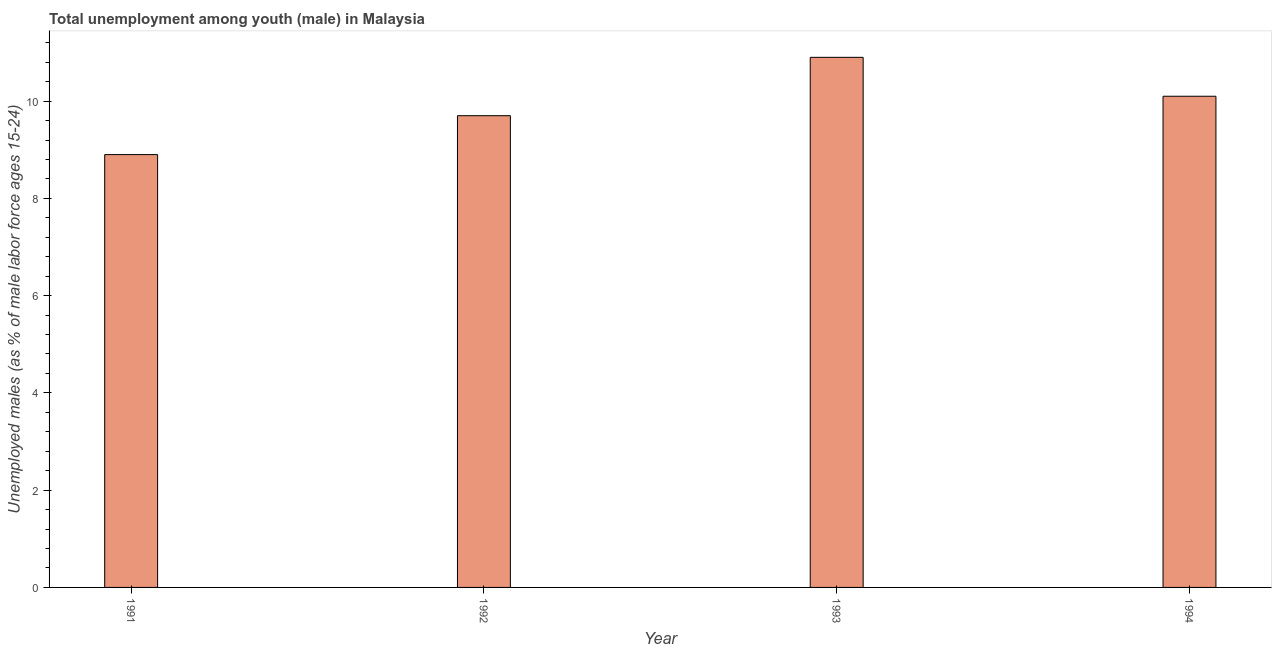What is the title of the graph?
Make the answer very short. Total unemployment among youth (male) in Malaysia. What is the label or title of the Y-axis?
Your answer should be compact. Unemployed males (as % of male labor force ages 15-24). What is the unemployed male youth population in 1991?
Your answer should be very brief. 8.9. Across all years, what is the maximum unemployed male youth population?
Give a very brief answer. 10.9. Across all years, what is the minimum unemployed male youth population?
Your response must be concise. 8.9. In which year was the unemployed male youth population minimum?
Ensure brevity in your answer.  1991. What is the sum of the unemployed male youth population?
Offer a very short reply. 39.6. What is the difference between the unemployed male youth population in 1991 and 1993?
Keep it short and to the point. -2. What is the average unemployed male youth population per year?
Provide a short and direct response. 9.9. What is the median unemployed male youth population?
Your answer should be very brief. 9.9. Do a majority of the years between 1991 and 1994 (inclusive) have unemployed male youth population greater than 2 %?
Your answer should be very brief. Yes. What is the ratio of the unemployed male youth population in 1993 to that in 1994?
Keep it short and to the point. 1.08. Is the unemployed male youth population in 1991 less than that in 1993?
Ensure brevity in your answer.  Yes. What is the difference between the highest and the second highest unemployed male youth population?
Give a very brief answer. 0.8. Is the sum of the unemployed male youth population in 1991 and 1993 greater than the maximum unemployed male youth population across all years?
Offer a very short reply. Yes. What is the difference between the highest and the lowest unemployed male youth population?
Ensure brevity in your answer.  2. In how many years, is the unemployed male youth population greater than the average unemployed male youth population taken over all years?
Offer a terse response. 2. Are all the bars in the graph horizontal?
Provide a short and direct response. No. What is the difference between two consecutive major ticks on the Y-axis?
Your answer should be very brief. 2. Are the values on the major ticks of Y-axis written in scientific E-notation?
Your response must be concise. No. What is the Unemployed males (as % of male labor force ages 15-24) in 1991?
Provide a short and direct response. 8.9. What is the Unemployed males (as % of male labor force ages 15-24) of 1992?
Your response must be concise. 9.7. What is the Unemployed males (as % of male labor force ages 15-24) in 1993?
Provide a short and direct response. 10.9. What is the Unemployed males (as % of male labor force ages 15-24) in 1994?
Provide a short and direct response. 10.1. What is the difference between the Unemployed males (as % of male labor force ages 15-24) in 1992 and 1993?
Ensure brevity in your answer.  -1.2. What is the difference between the Unemployed males (as % of male labor force ages 15-24) in 1993 and 1994?
Ensure brevity in your answer.  0.8. What is the ratio of the Unemployed males (as % of male labor force ages 15-24) in 1991 to that in 1992?
Give a very brief answer. 0.92. What is the ratio of the Unemployed males (as % of male labor force ages 15-24) in 1991 to that in 1993?
Keep it short and to the point. 0.82. What is the ratio of the Unemployed males (as % of male labor force ages 15-24) in 1991 to that in 1994?
Keep it short and to the point. 0.88. What is the ratio of the Unemployed males (as % of male labor force ages 15-24) in 1992 to that in 1993?
Provide a succinct answer. 0.89. What is the ratio of the Unemployed males (as % of male labor force ages 15-24) in 1993 to that in 1994?
Your answer should be compact. 1.08. 